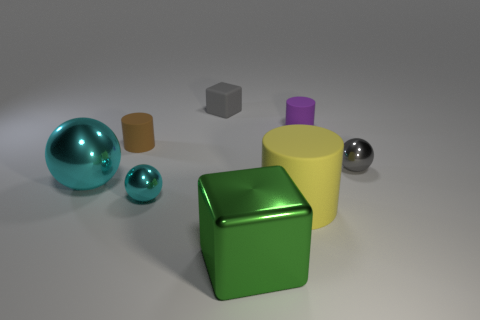How many cyan shiny things are there?
Give a very brief answer. 2. There is a ball to the right of the big green metallic cube; what material is it?
Your answer should be very brief. Metal. There is a tiny purple thing; are there any rubber objects left of it?
Make the answer very short. Yes. Is the size of the gray rubber cube the same as the purple matte cylinder?
Your answer should be very brief. Yes. How many yellow cylinders have the same material as the tiny cube?
Your response must be concise. 1. What is the size of the block in front of the metal sphere to the left of the small cyan metal sphere?
Your response must be concise. Large. What is the color of the thing that is right of the big green metallic thing and in front of the gray ball?
Give a very brief answer. Yellow. Does the purple object have the same shape as the small brown rubber thing?
Offer a very short reply. Yes. There is a tiny gray object behind the shiny object that is behind the big sphere; what shape is it?
Ensure brevity in your answer.  Cube. There is a big green shiny thing; does it have the same shape as the gray object on the left side of the big green metal thing?
Make the answer very short. Yes. 